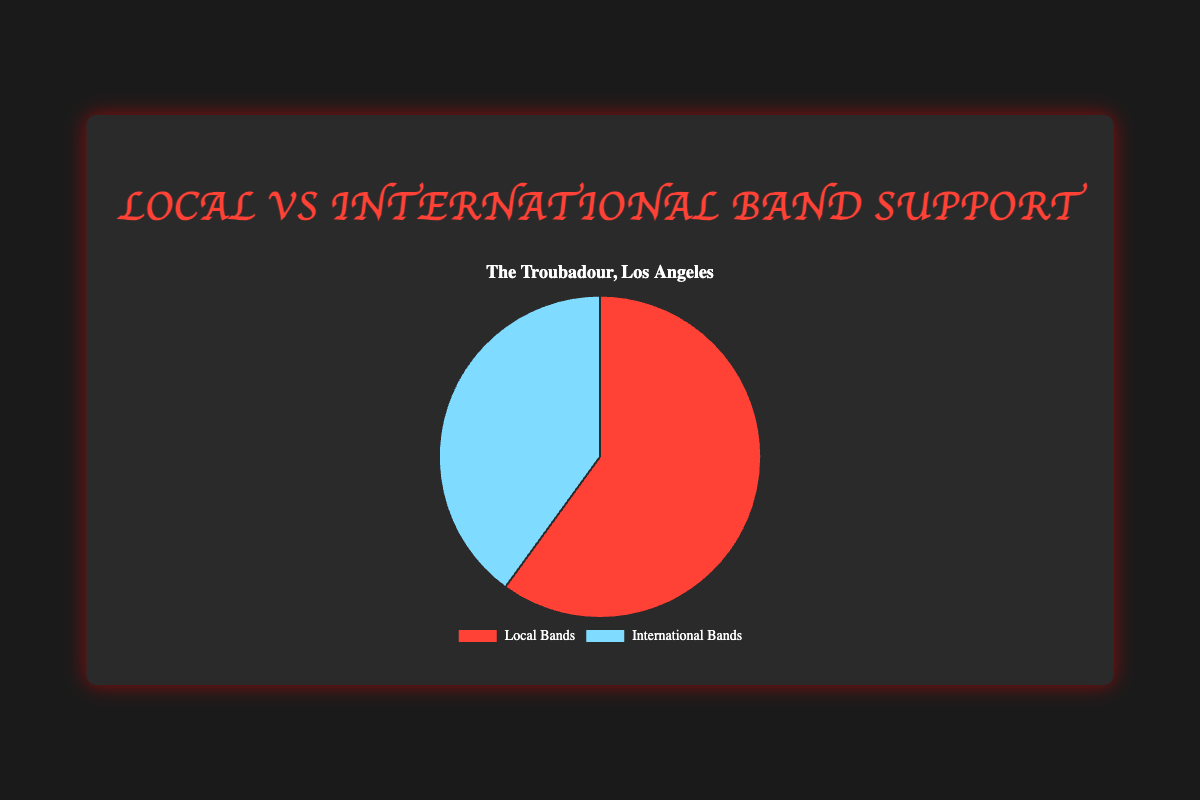What percentage of support does The Troubadour in Los Angeles give to local bands compared to international bands? From the pie chart, it is clear that The Troubadour in Los Angeles supports local bands 60% and international bands 40%.
Answer: 60% to 40% Which type of band has more support in The Troubadour, Los Angeles, and by how much? From the pie chart, local bands have 60% support while international bands have 40%. Local bands are supported 20% more than international bands.
Answer: Local bands by 20% Calculate the difference in support between local and international bands at The Troubadour. The support for local bands is 60% and for international bands is 40%, so the difference is 60% - 40% = 20%.
Answer: 20% What is the sum of support percentages for both the local and international bands at The Troubadour? By adding the support percentages for local bands (60%) and international bands (40%), the total is 60% + 40% = 100%.
Answer: 100% Compare the support for local bands in Saint Vitus, Brooklyn, to The Troubadour, Los Angeles. Saint Vitus supports local bands at 70% and The Troubadour supports local bands at 60%. Saint Vitus supports local bands 10% more.
Answer: 10% more at Saint Vitus Identify the portion of the pie chart that represents support for international bands at The Troubadour and its color. The portion representing international bands is 40% and is depicted in a blue color.
Answer: 40%, blue Which support percentage is shown in red on the pie chart? The red-colored section represents 60%, which corresponds to the support for local bands.
Answer: 60% If the support percentage for local bands increases by 10% at The Troubadour, what will be the new percentage? Current support for local bands is 60%. If increased by 10%, the new percentage is 60% + 10% = 70%.
Answer: 70% Calculate the average support for local bands across The Troubadour, Saint Vitus, and Slim's. The support for local bands is 60% (The Troubadour), 70% (Saint Vitus), and 55% (Slim's). Sum these values: 60% + 70% + 55% = 185%. Divide by 3: 185%/3 ≈ 61.67%.
Answer: 61.67% By how much does support for international bands need to increase at The Troubadour to equal that of local bands? Currently, local bands have 60% support and international bands have 40% support. To equal local bands at 60%, international bands need an increase of 60% - 40% = 20%.
Answer: 20% 